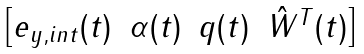Convert formula to latex. <formula><loc_0><loc_0><loc_500><loc_500>\begin{bmatrix} { e } _ { y , i n t } ( t ) & \alpha ( t ) & q ( t ) & \hat { W } ^ { T } ( t ) \end{bmatrix}</formula> 